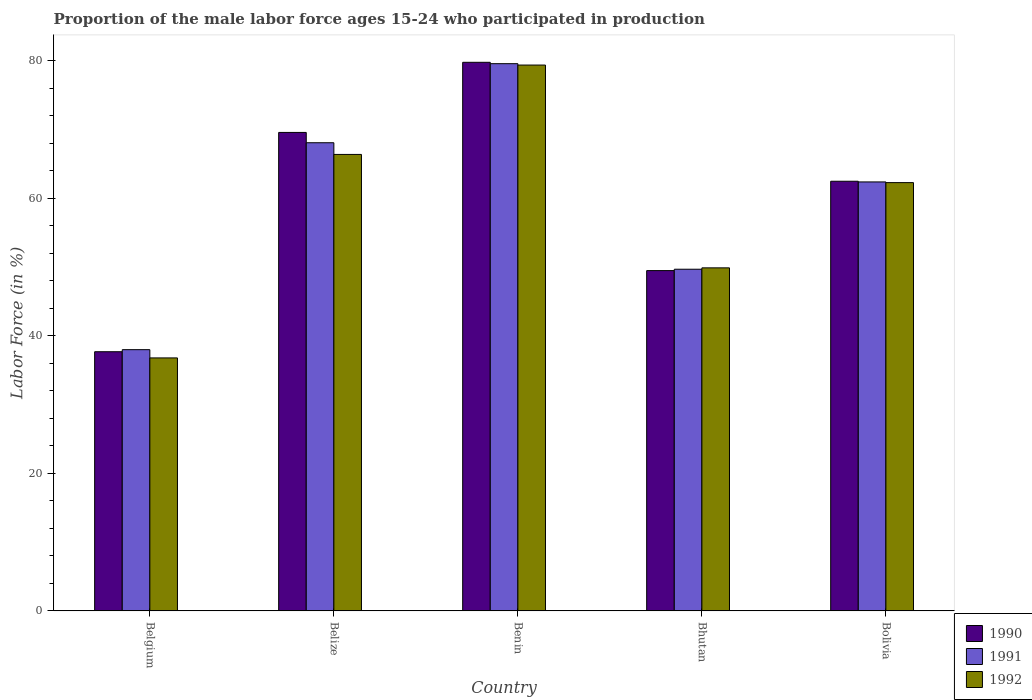How many different coloured bars are there?
Offer a very short reply. 3. Are the number of bars per tick equal to the number of legend labels?
Make the answer very short. Yes. Are the number of bars on each tick of the X-axis equal?
Provide a short and direct response. Yes. What is the label of the 2nd group of bars from the left?
Provide a succinct answer. Belize. What is the proportion of the male labor force who participated in production in 1990 in Benin?
Give a very brief answer. 79.8. Across all countries, what is the maximum proportion of the male labor force who participated in production in 1991?
Keep it short and to the point. 79.6. Across all countries, what is the minimum proportion of the male labor force who participated in production in 1991?
Ensure brevity in your answer.  38. In which country was the proportion of the male labor force who participated in production in 1992 maximum?
Provide a short and direct response. Benin. What is the total proportion of the male labor force who participated in production in 1990 in the graph?
Make the answer very short. 299.1. What is the difference between the proportion of the male labor force who participated in production in 1991 in Belgium and that in Benin?
Your answer should be very brief. -41.6. What is the difference between the proportion of the male labor force who participated in production in 1991 in Belgium and the proportion of the male labor force who participated in production in 1992 in Bolivia?
Your answer should be compact. -24.3. What is the average proportion of the male labor force who participated in production in 1992 per country?
Offer a terse response. 58.96. What is the difference between the proportion of the male labor force who participated in production of/in 1992 and proportion of the male labor force who participated in production of/in 1990 in Belize?
Keep it short and to the point. -3.2. What is the ratio of the proportion of the male labor force who participated in production in 1992 in Benin to that in Bhutan?
Offer a very short reply. 1.59. Is the proportion of the male labor force who participated in production in 1990 in Belgium less than that in Bolivia?
Your response must be concise. Yes. What is the difference between the highest and the second highest proportion of the male labor force who participated in production in 1990?
Keep it short and to the point. 7.1. What is the difference between the highest and the lowest proportion of the male labor force who participated in production in 1992?
Make the answer very short. 42.6. Is the sum of the proportion of the male labor force who participated in production in 1990 in Belgium and Bolivia greater than the maximum proportion of the male labor force who participated in production in 1991 across all countries?
Your answer should be very brief. Yes. What does the 1st bar from the left in Benin represents?
Give a very brief answer. 1990. Is it the case that in every country, the sum of the proportion of the male labor force who participated in production in 1992 and proportion of the male labor force who participated in production in 1990 is greater than the proportion of the male labor force who participated in production in 1991?
Ensure brevity in your answer.  Yes. How many bars are there?
Keep it short and to the point. 15. Are all the bars in the graph horizontal?
Ensure brevity in your answer.  No. Are the values on the major ticks of Y-axis written in scientific E-notation?
Ensure brevity in your answer.  No. Does the graph contain any zero values?
Keep it short and to the point. No. Does the graph contain grids?
Your answer should be compact. No. How many legend labels are there?
Provide a succinct answer. 3. How are the legend labels stacked?
Your answer should be compact. Vertical. What is the title of the graph?
Keep it short and to the point. Proportion of the male labor force ages 15-24 who participated in production. What is the label or title of the X-axis?
Provide a short and direct response. Country. What is the label or title of the Y-axis?
Provide a short and direct response. Labor Force (in %). What is the Labor Force (in %) of 1990 in Belgium?
Offer a terse response. 37.7. What is the Labor Force (in %) of 1992 in Belgium?
Offer a terse response. 36.8. What is the Labor Force (in %) of 1990 in Belize?
Offer a terse response. 69.6. What is the Labor Force (in %) of 1991 in Belize?
Make the answer very short. 68.1. What is the Labor Force (in %) of 1992 in Belize?
Your response must be concise. 66.4. What is the Labor Force (in %) of 1990 in Benin?
Your answer should be compact. 79.8. What is the Labor Force (in %) in 1991 in Benin?
Give a very brief answer. 79.6. What is the Labor Force (in %) in 1992 in Benin?
Keep it short and to the point. 79.4. What is the Labor Force (in %) of 1990 in Bhutan?
Your answer should be compact. 49.5. What is the Labor Force (in %) of 1991 in Bhutan?
Provide a succinct answer. 49.7. What is the Labor Force (in %) of 1992 in Bhutan?
Offer a very short reply. 49.9. What is the Labor Force (in %) of 1990 in Bolivia?
Make the answer very short. 62.5. What is the Labor Force (in %) in 1991 in Bolivia?
Keep it short and to the point. 62.4. What is the Labor Force (in %) in 1992 in Bolivia?
Your response must be concise. 62.3. Across all countries, what is the maximum Labor Force (in %) in 1990?
Your answer should be very brief. 79.8. Across all countries, what is the maximum Labor Force (in %) of 1991?
Offer a terse response. 79.6. Across all countries, what is the maximum Labor Force (in %) of 1992?
Provide a succinct answer. 79.4. Across all countries, what is the minimum Labor Force (in %) of 1990?
Offer a terse response. 37.7. Across all countries, what is the minimum Labor Force (in %) in 1992?
Ensure brevity in your answer.  36.8. What is the total Labor Force (in %) of 1990 in the graph?
Offer a terse response. 299.1. What is the total Labor Force (in %) of 1991 in the graph?
Give a very brief answer. 297.8. What is the total Labor Force (in %) in 1992 in the graph?
Provide a succinct answer. 294.8. What is the difference between the Labor Force (in %) of 1990 in Belgium and that in Belize?
Ensure brevity in your answer.  -31.9. What is the difference between the Labor Force (in %) of 1991 in Belgium and that in Belize?
Offer a terse response. -30.1. What is the difference between the Labor Force (in %) in 1992 in Belgium and that in Belize?
Your answer should be very brief. -29.6. What is the difference between the Labor Force (in %) in 1990 in Belgium and that in Benin?
Your answer should be very brief. -42.1. What is the difference between the Labor Force (in %) in 1991 in Belgium and that in Benin?
Make the answer very short. -41.6. What is the difference between the Labor Force (in %) of 1992 in Belgium and that in Benin?
Your answer should be very brief. -42.6. What is the difference between the Labor Force (in %) in 1990 in Belgium and that in Bhutan?
Your response must be concise. -11.8. What is the difference between the Labor Force (in %) of 1990 in Belgium and that in Bolivia?
Provide a succinct answer. -24.8. What is the difference between the Labor Force (in %) in 1991 in Belgium and that in Bolivia?
Your response must be concise. -24.4. What is the difference between the Labor Force (in %) in 1992 in Belgium and that in Bolivia?
Keep it short and to the point. -25.5. What is the difference between the Labor Force (in %) of 1990 in Belize and that in Benin?
Provide a succinct answer. -10.2. What is the difference between the Labor Force (in %) of 1992 in Belize and that in Benin?
Keep it short and to the point. -13. What is the difference between the Labor Force (in %) in 1990 in Belize and that in Bhutan?
Make the answer very short. 20.1. What is the difference between the Labor Force (in %) of 1991 in Belize and that in Bhutan?
Ensure brevity in your answer.  18.4. What is the difference between the Labor Force (in %) in 1992 in Belize and that in Bhutan?
Provide a short and direct response. 16.5. What is the difference between the Labor Force (in %) in 1992 in Belize and that in Bolivia?
Keep it short and to the point. 4.1. What is the difference between the Labor Force (in %) of 1990 in Benin and that in Bhutan?
Your answer should be very brief. 30.3. What is the difference between the Labor Force (in %) in 1991 in Benin and that in Bhutan?
Offer a very short reply. 29.9. What is the difference between the Labor Force (in %) in 1992 in Benin and that in Bhutan?
Your response must be concise. 29.5. What is the difference between the Labor Force (in %) in 1990 in Benin and that in Bolivia?
Provide a succinct answer. 17.3. What is the difference between the Labor Force (in %) of 1992 in Benin and that in Bolivia?
Offer a very short reply. 17.1. What is the difference between the Labor Force (in %) in 1990 in Bhutan and that in Bolivia?
Provide a succinct answer. -13. What is the difference between the Labor Force (in %) of 1991 in Bhutan and that in Bolivia?
Give a very brief answer. -12.7. What is the difference between the Labor Force (in %) in 1992 in Bhutan and that in Bolivia?
Give a very brief answer. -12.4. What is the difference between the Labor Force (in %) in 1990 in Belgium and the Labor Force (in %) in 1991 in Belize?
Offer a very short reply. -30.4. What is the difference between the Labor Force (in %) in 1990 in Belgium and the Labor Force (in %) in 1992 in Belize?
Provide a succinct answer. -28.7. What is the difference between the Labor Force (in %) of 1991 in Belgium and the Labor Force (in %) of 1992 in Belize?
Your answer should be compact. -28.4. What is the difference between the Labor Force (in %) in 1990 in Belgium and the Labor Force (in %) in 1991 in Benin?
Offer a terse response. -41.9. What is the difference between the Labor Force (in %) of 1990 in Belgium and the Labor Force (in %) of 1992 in Benin?
Ensure brevity in your answer.  -41.7. What is the difference between the Labor Force (in %) in 1991 in Belgium and the Labor Force (in %) in 1992 in Benin?
Provide a succinct answer. -41.4. What is the difference between the Labor Force (in %) of 1991 in Belgium and the Labor Force (in %) of 1992 in Bhutan?
Offer a very short reply. -11.9. What is the difference between the Labor Force (in %) of 1990 in Belgium and the Labor Force (in %) of 1991 in Bolivia?
Make the answer very short. -24.7. What is the difference between the Labor Force (in %) in 1990 in Belgium and the Labor Force (in %) in 1992 in Bolivia?
Your response must be concise. -24.6. What is the difference between the Labor Force (in %) of 1991 in Belgium and the Labor Force (in %) of 1992 in Bolivia?
Provide a succinct answer. -24.3. What is the difference between the Labor Force (in %) in 1990 in Belize and the Labor Force (in %) in 1992 in Benin?
Keep it short and to the point. -9.8. What is the difference between the Labor Force (in %) in 1990 in Belize and the Labor Force (in %) in 1992 in Bhutan?
Offer a terse response. 19.7. What is the difference between the Labor Force (in %) of 1990 in Belize and the Labor Force (in %) of 1992 in Bolivia?
Offer a terse response. 7.3. What is the difference between the Labor Force (in %) of 1991 in Belize and the Labor Force (in %) of 1992 in Bolivia?
Provide a succinct answer. 5.8. What is the difference between the Labor Force (in %) of 1990 in Benin and the Labor Force (in %) of 1991 in Bhutan?
Offer a terse response. 30.1. What is the difference between the Labor Force (in %) of 1990 in Benin and the Labor Force (in %) of 1992 in Bhutan?
Your answer should be compact. 29.9. What is the difference between the Labor Force (in %) in 1991 in Benin and the Labor Force (in %) in 1992 in Bhutan?
Offer a very short reply. 29.7. What is the difference between the Labor Force (in %) in 1990 in Benin and the Labor Force (in %) in 1992 in Bolivia?
Offer a terse response. 17.5. What is the difference between the Labor Force (in %) in 1991 in Benin and the Labor Force (in %) in 1992 in Bolivia?
Offer a terse response. 17.3. What is the difference between the Labor Force (in %) of 1990 in Bhutan and the Labor Force (in %) of 1992 in Bolivia?
Make the answer very short. -12.8. What is the average Labor Force (in %) in 1990 per country?
Offer a very short reply. 59.82. What is the average Labor Force (in %) of 1991 per country?
Provide a short and direct response. 59.56. What is the average Labor Force (in %) of 1992 per country?
Make the answer very short. 58.96. What is the difference between the Labor Force (in %) of 1990 and Labor Force (in %) of 1992 in Belgium?
Ensure brevity in your answer.  0.9. What is the difference between the Labor Force (in %) of 1991 and Labor Force (in %) of 1992 in Belgium?
Provide a succinct answer. 1.2. What is the difference between the Labor Force (in %) in 1990 and Labor Force (in %) in 1991 in Belize?
Provide a short and direct response. 1.5. What is the difference between the Labor Force (in %) in 1991 and Labor Force (in %) in 1992 in Benin?
Keep it short and to the point. 0.2. What is the difference between the Labor Force (in %) of 1990 and Labor Force (in %) of 1992 in Bhutan?
Keep it short and to the point. -0.4. What is the difference between the Labor Force (in %) of 1991 and Labor Force (in %) of 1992 in Bhutan?
Your answer should be very brief. -0.2. What is the difference between the Labor Force (in %) of 1990 and Labor Force (in %) of 1991 in Bolivia?
Make the answer very short. 0.1. What is the difference between the Labor Force (in %) of 1991 and Labor Force (in %) of 1992 in Bolivia?
Ensure brevity in your answer.  0.1. What is the ratio of the Labor Force (in %) of 1990 in Belgium to that in Belize?
Offer a very short reply. 0.54. What is the ratio of the Labor Force (in %) of 1991 in Belgium to that in Belize?
Make the answer very short. 0.56. What is the ratio of the Labor Force (in %) in 1992 in Belgium to that in Belize?
Provide a succinct answer. 0.55. What is the ratio of the Labor Force (in %) in 1990 in Belgium to that in Benin?
Your response must be concise. 0.47. What is the ratio of the Labor Force (in %) in 1991 in Belgium to that in Benin?
Give a very brief answer. 0.48. What is the ratio of the Labor Force (in %) of 1992 in Belgium to that in Benin?
Your answer should be compact. 0.46. What is the ratio of the Labor Force (in %) in 1990 in Belgium to that in Bhutan?
Keep it short and to the point. 0.76. What is the ratio of the Labor Force (in %) in 1991 in Belgium to that in Bhutan?
Provide a succinct answer. 0.76. What is the ratio of the Labor Force (in %) of 1992 in Belgium to that in Bhutan?
Your answer should be compact. 0.74. What is the ratio of the Labor Force (in %) in 1990 in Belgium to that in Bolivia?
Ensure brevity in your answer.  0.6. What is the ratio of the Labor Force (in %) in 1991 in Belgium to that in Bolivia?
Keep it short and to the point. 0.61. What is the ratio of the Labor Force (in %) in 1992 in Belgium to that in Bolivia?
Ensure brevity in your answer.  0.59. What is the ratio of the Labor Force (in %) in 1990 in Belize to that in Benin?
Keep it short and to the point. 0.87. What is the ratio of the Labor Force (in %) in 1991 in Belize to that in Benin?
Your answer should be very brief. 0.86. What is the ratio of the Labor Force (in %) in 1992 in Belize to that in Benin?
Make the answer very short. 0.84. What is the ratio of the Labor Force (in %) of 1990 in Belize to that in Bhutan?
Provide a short and direct response. 1.41. What is the ratio of the Labor Force (in %) in 1991 in Belize to that in Bhutan?
Ensure brevity in your answer.  1.37. What is the ratio of the Labor Force (in %) of 1992 in Belize to that in Bhutan?
Provide a succinct answer. 1.33. What is the ratio of the Labor Force (in %) of 1990 in Belize to that in Bolivia?
Offer a very short reply. 1.11. What is the ratio of the Labor Force (in %) of 1991 in Belize to that in Bolivia?
Offer a terse response. 1.09. What is the ratio of the Labor Force (in %) in 1992 in Belize to that in Bolivia?
Your response must be concise. 1.07. What is the ratio of the Labor Force (in %) of 1990 in Benin to that in Bhutan?
Keep it short and to the point. 1.61. What is the ratio of the Labor Force (in %) in 1991 in Benin to that in Bhutan?
Provide a short and direct response. 1.6. What is the ratio of the Labor Force (in %) of 1992 in Benin to that in Bhutan?
Offer a terse response. 1.59. What is the ratio of the Labor Force (in %) of 1990 in Benin to that in Bolivia?
Your answer should be compact. 1.28. What is the ratio of the Labor Force (in %) of 1991 in Benin to that in Bolivia?
Make the answer very short. 1.28. What is the ratio of the Labor Force (in %) of 1992 in Benin to that in Bolivia?
Ensure brevity in your answer.  1.27. What is the ratio of the Labor Force (in %) in 1990 in Bhutan to that in Bolivia?
Your answer should be very brief. 0.79. What is the ratio of the Labor Force (in %) of 1991 in Bhutan to that in Bolivia?
Your answer should be compact. 0.8. What is the ratio of the Labor Force (in %) of 1992 in Bhutan to that in Bolivia?
Your response must be concise. 0.8. What is the difference between the highest and the lowest Labor Force (in %) in 1990?
Your response must be concise. 42.1. What is the difference between the highest and the lowest Labor Force (in %) in 1991?
Your answer should be very brief. 41.6. What is the difference between the highest and the lowest Labor Force (in %) in 1992?
Give a very brief answer. 42.6. 